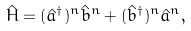<formula> <loc_0><loc_0><loc_500><loc_500>\hat { H } = ( \hat { a } ^ { \dagger } ) ^ { n } \hat { b } ^ { n } + ( \hat { b } ^ { \dagger } ) ^ { n } \hat { a } ^ { n } ,</formula> 